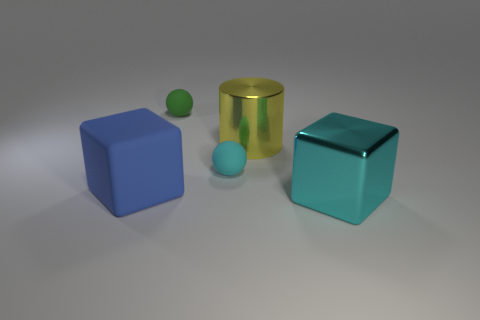There is a cube that is on the left side of the cyan sphere; what is its size?
Give a very brief answer. Large. Do the yellow metal cylinder and the green thing have the same size?
Ensure brevity in your answer.  No. Is the number of blue rubber things to the left of the green thing less than the number of yellow metal cylinders left of the large metal cylinder?
Your answer should be compact. No. What size is the thing that is both to the right of the cyan matte thing and in front of the yellow thing?
Your answer should be compact. Large. Is there a blue rubber block on the right side of the big metallic object that is behind the large metal block that is in front of the rubber cube?
Offer a terse response. No. Are any gray matte spheres visible?
Your answer should be very brief. No. Are there more cyan blocks behind the tiny cyan ball than cyan rubber balls that are to the right of the cylinder?
Your answer should be compact. No. There is a cyan sphere that is the same material as the tiny green ball; what size is it?
Give a very brief answer. Small. There is a matte ball that is left of the tiny rubber sphere that is in front of the ball that is behind the small cyan ball; what size is it?
Offer a terse response. Small. There is a metallic thing that is behind the rubber block; what is its color?
Offer a very short reply. Yellow. 